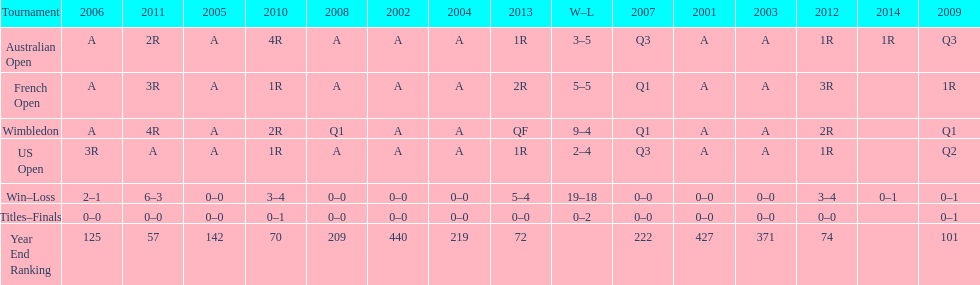In which year was the end ranking higher - 2004 or 2011? 2011. Parse the table in full. {'header': ['Tournament', '2006', '2011', '2005', '2010', '2008', '2002', '2004', '2013', 'W–L', '2007', '2001', '2003', '2012', '2014', '2009'], 'rows': [['Australian Open', 'A', '2R', 'A', '4R', 'A', 'A', 'A', '1R', '3–5', 'Q3', 'A', 'A', '1R', '1R', 'Q3'], ['French Open', 'A', '3R', 'A', '1R', 'A', 'A', 'A', '2R', '5–5', 'Q1', 'A', 'A', '3R', '', '1R'], ['Wimbledon', 'A', '4R', 'A', '2R', 'Q1', 'A', 'A', 'QF', '9–4', 'Q1', 'A', 'A', '2R', '', 'Q1'], ['US Open', '3R', 'A', 'A', '1R', 'A', 'A', 'A', '1R', '2–4', 'Q3', 'A', 'A', '1R', '', 'Q2'], ['Win–Loss', '2–1', '6–3', '0–0', '3–4', '0–0', '0–0', '0–0', '5–4', '19–18', '0–0', '0–0', '0–0', '3–4', '0–1', '0–1'], ['Titles–Finals', '0–0', '0–0', '0–0', '0–1', '0–0', '0–0', '0–0', '0–0', '0–2', '0–0', '0–0', '0–0', '0–0', '', '0–1'], ['Year End Ranking', '125', '57', '142', '70', '209', '440', '219', '72', '', '222', '427', '371', '74', '', '101']]} 